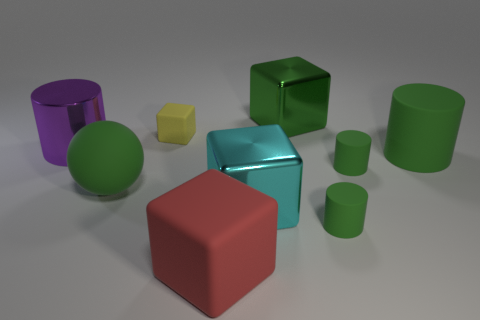Is there anything else that is the same shape as the large red object?
Give a very brief answer. Yes. Are there an equal number of yellow rubber things that are in front of the red rubber thing and cyan objects?
Your answer should be compact. No. There is a large matte cylinder; does it have the same color as the big metallic block that is in front of the tiny matte block?
Keep it short and to the point. No. What color is the object that is on the right side of the big cyan thing and behind the large purple thing?
Offer a terse response. Green. What number of objects are in front of the large green thing to the left of the small yellow matte thing?
Give a very brief answer. 3. Is there a tiny blue object of the same shape as the large purple object?
Your response must be concise. No. Does the tiny thing on the left side of the large cyan cube have the same shape as the shiny thing that is right of the large cyan object?
Ensure brevity in your answer.  Yes. What number of objects are rubber balls or red matte blocks?
Your answer should be compact. 2. The yellow thing that is the same shape as the cyan metal thing is what size?
Your answer should be compact. Small. Is the number of tiny matte things that are left of the red thing greater than the number of tiny shiny cubes?
Give a very brief answer. Yes. 